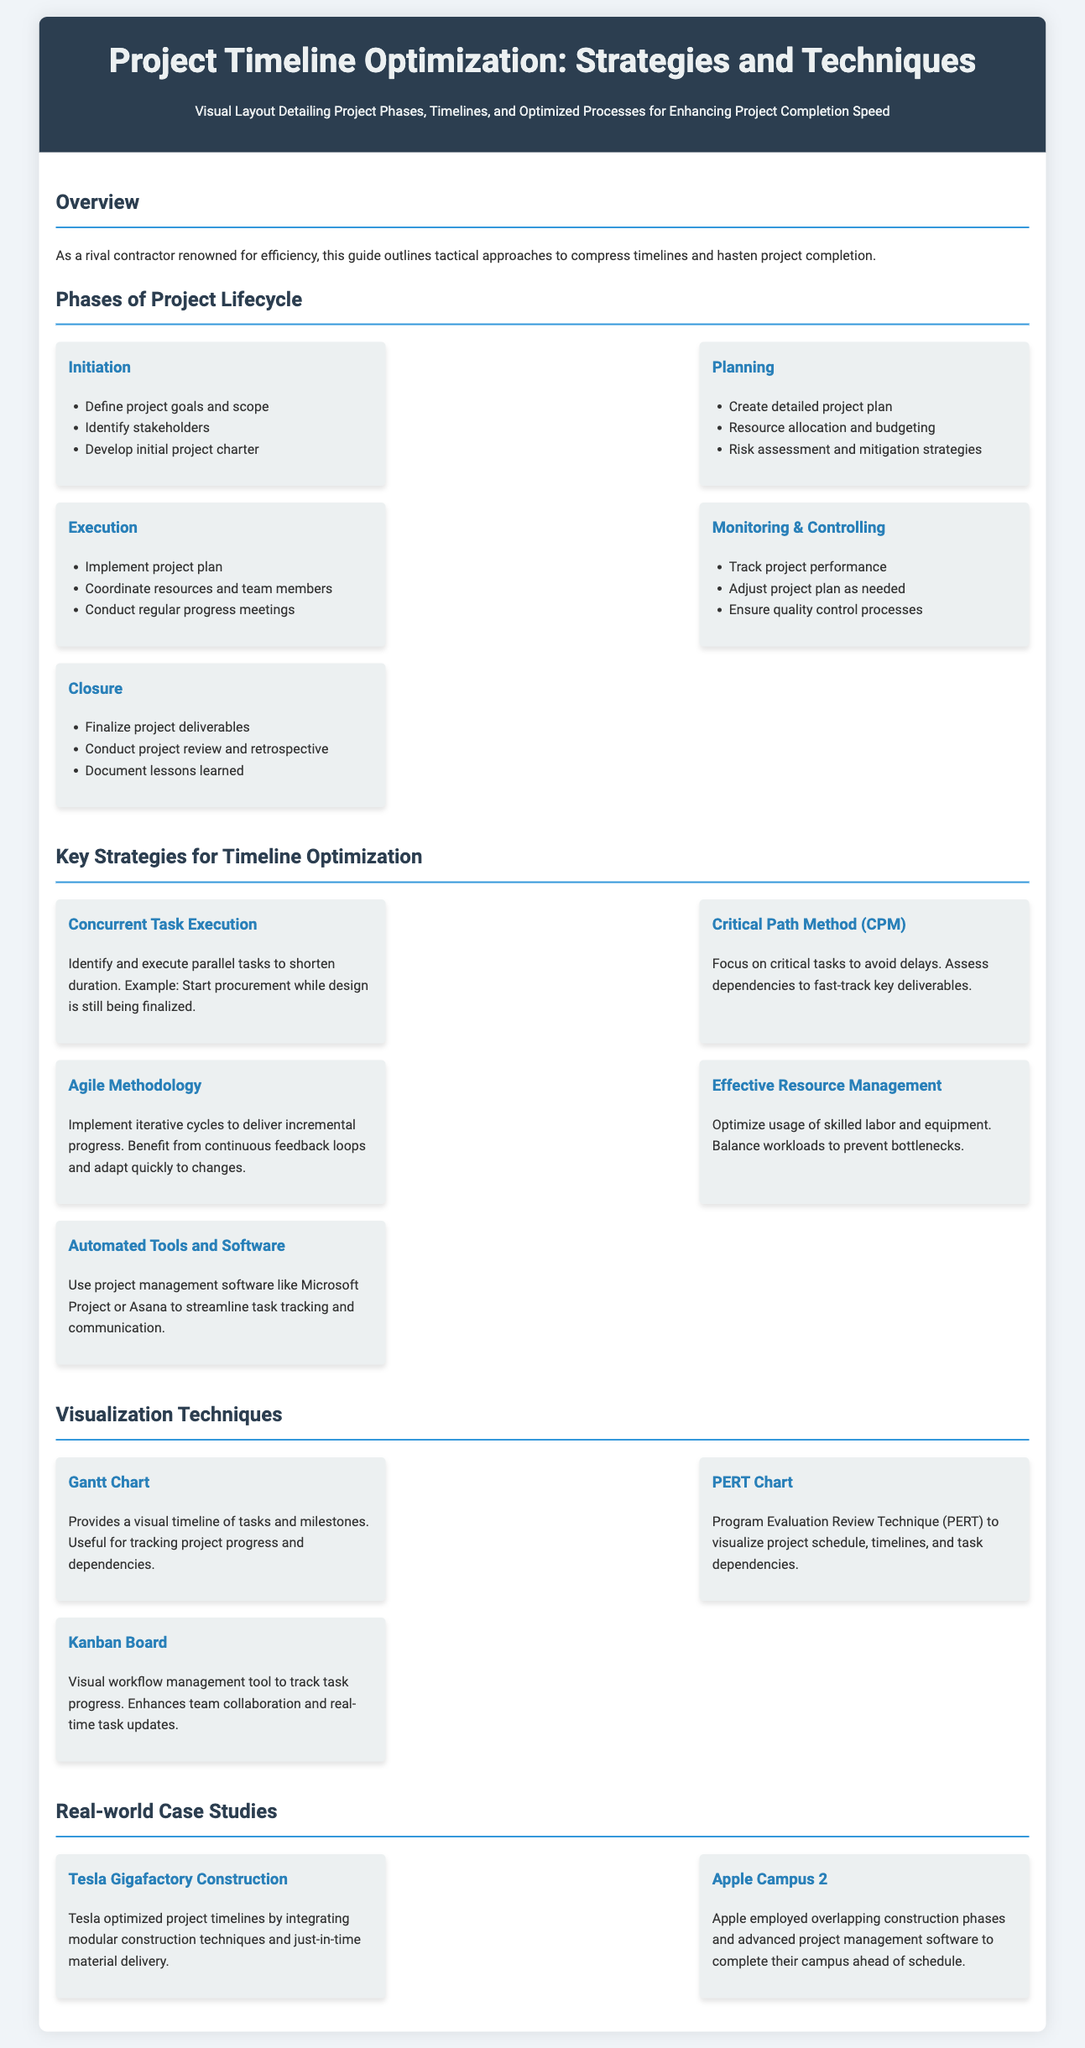what are the phases of the project lifecycle? The document lists five phases: Initiation, Planning, Execution, Monitoring & Controlling, and Closure.
Answer: Initiation, Planning, Execution, Monitoring & Controlling, Closure what is the key strategy focusing on critical tasks? This strategy helps avoid delays by assessing dependencies and fast-tracking key deliverables.
Answer: Critical Path Method which visual technique tracks task progress in real-time? The document describes a tool that enhances team collaboration and task updates.
Answer: Kanban Board how many strategies for timeline optimization are mentioned? The document lists five key strategies for timeline optimization.
Answer: 5 name one real-world case study of project optimization. The document provides examples of projects that employed various strategies to complete ahead of schedule.
Answer: Tesla Gigafactory Construction what is the purpose of a Gantt Chart? This technique provides a visual timeline of tasks and milestones for tracking progress.
Answer: Visual timeline what is the benefit of utilizing agile methodology? This approach allows for iterative cycles, enabling quick adaptation to changes through feedback loops.
Answer: Incremental progress which phase includes conducting a project review? The phase focused on finalizing deliverables and assessing the project's success features this activity.
Answer: Closure what type of project management software did Apple use? This software helps in employing advanced techniques to complete projects ahead of schedule.
Answer: Project management software what does PERT stand for? The document mentions a specific technique for visualizing project schedules.
Answer: Program Evaluation Review Technique 